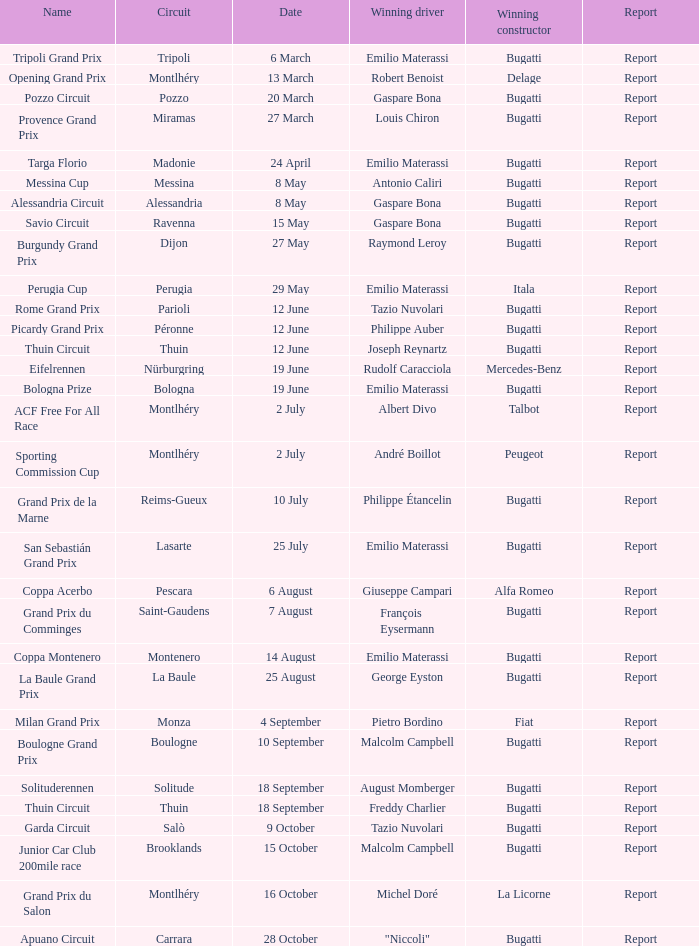When did Gaspare Bona win the Pozzo Circuit? 20 March. 